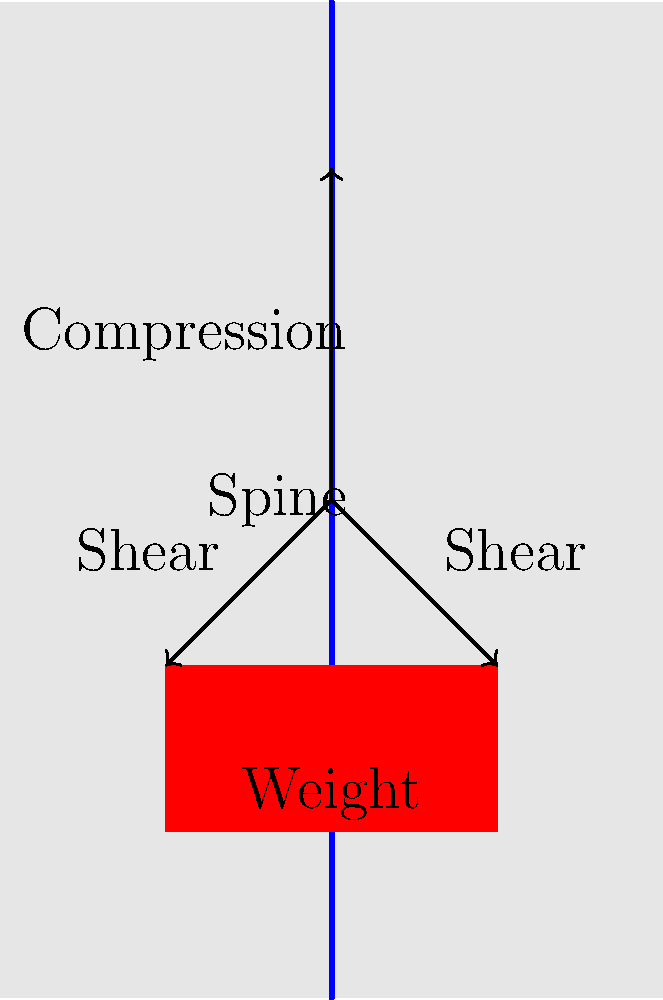In the context of biomechanics, when a person lifts a heavy object as shown in the diagram, how does the distribution of forces on the spine affect the risk of injury? Consider the compression and shear forces acting on the vertebrae. To understand the distribution of forces on the spine when lifting an object, let's break it down step-by-step:

1. Compression force:
   - When lifting a weight, the primary force acting on the spine is compression.
   - This force acts vertically along the length of the spine, pushing the vertebrae together.
   - The compression force is a result of the combined weight of the upper body and the lifted object.

2. Shear forces:
   - Shear forces act perpendicular to the spine's long axis.
   - These forces occur due to the angular positioning of the spine during lifting, especially if the person bends forward.
   - Shear forces can cause the vertebrae to slide relative to each other.

3. Force distribution:
   - The intervertebral discs between the vertebrae help distribute the compression forces evenly.
   - However, the discs are less effective at handling shear forces.

4. Risk factors:
   - Excessive compression can lead to disc herniation or vertebral fractures.
   - High shear forces increase the risk of disc degeneration and facet joint damage.
   - The combination of compression and shear forces puts significant stress on the lower back (lumbar region).

5. Proper lifting technique:
   - Keeping the object close to the body reduces the moment arm and decreases shear forces.
   - Lifting with a straight back and using leg muscles helps distribute the load more evenly.
   - This technique minimizes the bending moment on the spine, reducing injury risk.

6. Biomechanical considerations:
   - The spine's curvature (lordosis in the lumbar region) helps distribute forces more effectively.
   - Muscle tension in the back and abdominal muscles provides additional support to the spine.

Understanding these force distributions is crucial for developing safe lifting techniques and preventing spinal injuries in various occupational and everyday settings.
Answer: Compression and shear forces on the spine during lifting increase injury risk, particularly to intervertebral discs and vertebrae. Proper technique reduces these forces and minimizes injury risk. 